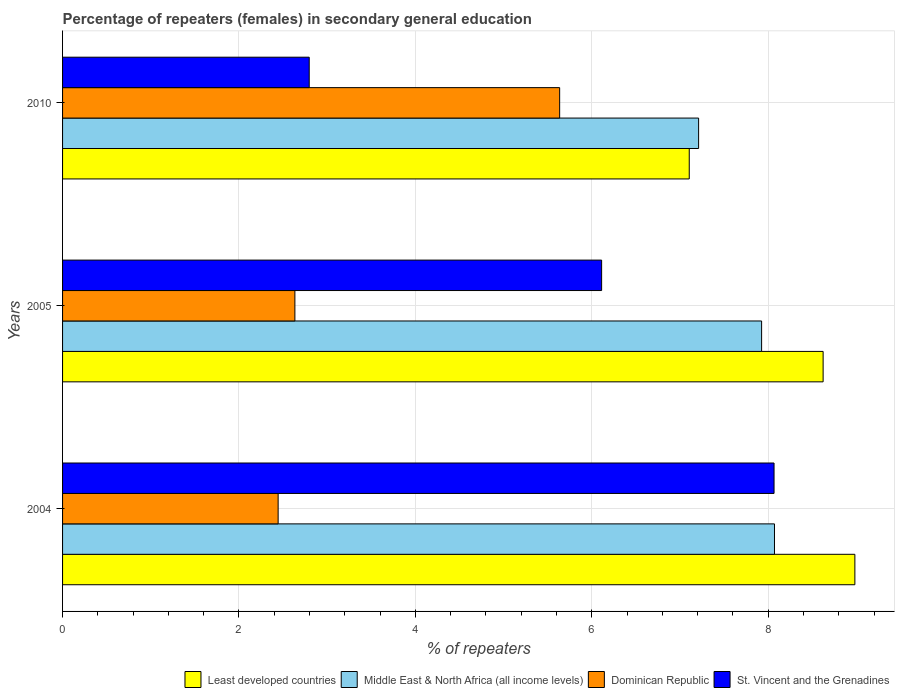How many bars are there on the 3rd tick from the top?
Keep it short and to the point. 4. How many bars are there on the 2nd tick from the bottom?
Your answer should be compact. 4. What is the label of the 2nd group of bars from the top?
Keep it short and to the point. 2005. What is the percentage of female repeaters in Middle East & North Africa (all income levels) in 2005?
Keep it short and to the point. 7.92. Across all years, what is the maximum percentage of female repeaters in Dominican Republic?
Your answer should be compact. 5.64. Across all years, what is the minimum percentage of female repeaters in Middle East & North Africa (all income levels)?
Give a very brief answer. 7.21. In which year was the percentage of female repeaters in Dominican Republic minimum?
Your answer should be very brief. 2004. What is the total percentage of female repeaters in St. Vincent and the Grenadines in the graph?
Your answer should be very brief. 16.97. What is the difference between the percentage of female repeaters in Dominican Republic in 2004 and that in 2010?
Make the answer very short. -3.19. What is the difference between the percentage of female repeaters in Dominican Republic in 2010 and the percentage of female repeaters in Middle East & North Africa (all income levels) in 2005?
Give a very brief answer. -2.29. What is the average percentage of female repeaters in St. Vincent and the Grenadines per year?
Provide a succinct answer. 5.66. In the year 2004, what is the difference between the percentage of female repeaters in St. Vincent and the Grenadines and percentage of female repeaters in Least developed countries?
Provide a succinct answer. -0.92. In how many years, is the percentage of female repeaters in Dominican Republic greater than 4 %?
Offer a very short reply. 1. What is the ratio of the percentage of female repeaters in Middle East & North Africa (all income levels) in 2004 to that in 2010?
Make the answer very short. 1.12. Is the difference between the percentage of female repeaters in St. Vincent and the Grenadines in 2004 and 2005 greater than the difference between the percentage of female repeaters in Least developed countries in 2004 and 2005?
Provide a succinct answer. Yes. What is the difference between the highest and the second highest percentage of female repeaters in Middle East & North Africa (all income levels)?
Ensure brevity in your answer.  0.15. What is the difference between the highest and the lowest percentage of female repeaters in Least developed countries?
Provide a short and direct response. 1.88. In how many years, is the percentage of female repeaters in Dominican Republic greater than the average percentage of female repeaters in Dominican Republic taken over all years?
Your response must be concise. 1. Is it the case that in every year, the sum of the percentage of female repeaters in Least developed countries and percentage of female repeaters in St. Vincent and the Grenadines is greater than the sum of percentage of female repeaters in Middle East & North Africa (all income levels) and percentage of female repeaters in Dominican Republic?
Give a very brief answer. No. What does the 1st bar from the top in 2005 represents?
Keep it short and to the point. St. Vincent and the Grenadines. What does the 3rd bar from the bottom in 2010 represents?
Give a very brief answer. Dominican Republic. Are all the bars in the graph horizontal?
Your answer should be very brief. Yes. How many years are there in the graph?
Provide a short and direct response. 3. Are the values on the major ticks of X-axis written in scientific E-notation?
Offer a very short reply. No. Does the graph contain any zero values?
Offer a very short reply. No. Does the graph contain grids?
Keep it short and to the point. Yes. Where does the legend appear in the graph?
Your answer should be compact. Bottom right. What is the title of the graph?
Ensure brevity in your answer.  Percentage of repeaters (females) in secondary general education. Does "United Kingdom" appear as one of the legend labels in the graph?
Provide a short and direct response. No. What is the label or title of the X-axis?
Your answer should be very brief. % of repeaters. What is the label or title of the Y-axis?
Provide a short and direct response. Years. What is the % of repeaters in Least developed countries in 2004?
Your answer should be compact. 8.98. What is the % of repeaters of Middle East & North Africa (all income levels) in 2004?
Your response must be concise. 8.07. What is the % of repeaters in Dominican Republic in 2004?
Provide a short and direct response. 2.44. What is the % of repeaters in St. Vincent and the Grenadines in 2004?
Provide a short and direct response. 8.07. What is the % of repeaters in Least developed countries in 2005?
Ensure brevity in your answer.  8.62. What is the % of repeaters in Middle East & North Africa (all income levels) in 2005?
Your answer should be very brief. 7.92. What is the % of repeaters in Dominican Republic in 2005?
Offer a very short reply. 2.63. What is the % of repeaters of St. Vincent and the Grenadines in 2005?
Your response must be concise. 6.11. What is the % of repeaters of Least developed countries in 2010?
Your answer should be very brief. 7.1. What is the % of repeaters in Middle East & North Africa (all income levels) in 2010?
Provide a short and direct response. 7.21. What is the % of repeaters in Dominican Republic in 2010?
Your answer should be very brief. 5.64. What is the % of repeaters in St. Vincent and the Grenadines in 2010?
Make the answer very short. 2.8. Across all years, what is the maximum % of repeaters of Least developed countries?
Your answer should be very brief. 8.98. Across all years, what is the maximum % of repeaters in Middle East & North Africa (all income levels)?
Give a very brief answer. 8.07. Across all years, what is the maximum % of repeaters of Dominican Republic?
Make the answer very short. 5.64. Across all years, what is the maximum % of repeaters in St. Vincent and the Grenadines?
Keep it short and to the point. 8.07. Across all years, what is the minimum % of repeaters of Least developed countries?
Your response must be concise. 7.1. Across all years, what is the minimum % of repeaters of Middle East & North Africa (all income levels)?
Give a very brief answer. 7.21. Across all years, what is the minimum % of repeaters in Dominican Republic?
Offer a terse response. 2.44. Across all years, what is the minimum % of repeaters of St. Vincent and the Grenadines?
Offer a terse response. 2.8. What is the total % of repeaters of Least developed countries in the graph?
Make the answer very short. 24.71. What is the total % of repeaters in Middle East & North Africa (all income levels) in the graph?
Provide a succinct answer. 23.21. What is the total % of repeaters in Dominican Republic in the graph?
Offer a terse response. 10.71. What is the total % of repeaters in St. Vincent and the Grenadines in the graph?
Your answer should be compact. 16.97. What is the difference between the % of repeaters of Least developed countries in 2004 and that in 2005?
Keep it short and to the point. 0.36. What is the difference between the % of repeaters of Middle East & North Africa (all income levels) in 2004 and that in 2005?
Your answer should be compact. 0.15. What is the difference between the % of repeaters in Dominican Republic in 2004 and that in 2005?
Provide a succinct answer. -0.19. What is the difference between the % of repeaters in St. Vincent and the Grenadines in 2004 and that in 2005?
Provide a succinct answer. 1.95. What is the difference between the % of repeaters in Least developed countries in 2004 and that in 2010?
Ensure brevity in your answer.  1.88. What is the difference between the % of repeaters of Middle East & North Africa (all income levels) in 2004 and that in 2010?
Make the answer very short. 0.86. What is the difference between the % of repeaters of Dominican Republic in 2004 and that in 2010?
Your response must be concise. -3.19. What is the difference between the % of repeaters in St. Vincent and the Grenadines in 2004 and that in 2010?
Give a very brief answer. 5.27. What is the difference between the % of repeaters of Least developed countries in 2005 and that in 2010?
Offer a very short reply. 1.52. What is the difference between the % of repeaters in Middle East & North Africa (all income levels) in 2005 and that in 2010?
Your response must be concise. 0.71. What is the difference between the % of repeaters of Dominican Republic in 2005 and that in 2010?
Provide a succinct answer. -3. What is the difference between the % of repeaters in St. Vincent and the Grenadines in 2005 and that in 2010?
Your answer should be compact. 3.31. What is the difference between the % of repeaters in Least developed countries in 2004 and the % of repeaters in Middle East & North Africa (all income levels) in 2005?
Provide a short and direct response. 1.06. What is the difference between the % of repeaters in Least developed countries in 2004 and the % of repeaters in Dominican Republic in 2005?
Keep it short and to the point. 6.35. What is the difference between the % of repeaters of Least developed countries in 2004 and the % of repeaters of St. Vincent and the Grenadines in 2005?
Ensure brevity in your answer.  2.87. What is the difference between the % of repeaters of Middle East & North Africa (all income levels) in 2004 and the % of repeaters of Dominican Republic in 2005?
Give a very brief answer. 5.44. What is the difference between the % of repeaters in Middle East & North Africa (all income levels) in 2004 and the % of repeaters in St. Vincent and the Grenadines in 2005?
Give a very brief answer. 1.96. What is the difference between the % of repeaters in Dominican Republic in 2004 and the % of repeaters in St. Vincent and the Grenadines in 2005?
Offer a very short reply. -3.67. What is the difference between the % of repeaters of Least developed countries in 2004 and the % of repeaters of Middle East & North Africa (all income levels) in 2010?
Provide a short and direct response. 1.77. What is the difference between the % of repeaters in Least developed countries in 2004 and the % of repeaters in Dominican Republic in 2010?
Give a very brief answer. 3.35. What is the difference between the % of repeaters of Least developed countries in 2004 and the % of repeaters of St. Vincent and the Grenadines in 2010?
Provide a short and direct response. 6.19. What is the difference between the % of repeaters in Middle East & North Africa (all income levels) in 2004 and the % of repeaters in Dominican Republic in 2010?
Your answer should be very brief. 2.44. What is the difference between the % of repeaters in Middle East & North Africa (all income levels) in 2004 and the % of repeaters in St. Vincent and the Grenadines in 2010?
Your response must be concise. 5.27. What is the difference between the % of repeaters in Dominican Republic in 2004 and the % of repeaters in St. Vincent and the Grenadines in 2010?
Give a very brief answer. -0.35. What is the difference between the % of repeaters of Least developed countries in 2005 and the % of repeaters of Middle East & North Africa (all income levels) in 2010?
Ensure brevity in your answer.  1.41. What is the difference between the % of repeaters in Least developed countries in 2005 and the % of repeaters in Dominican Republic in 2010?
Provide a succinct answer. 2.99. What is the difference between the % of repeaters in Least developed countries in 2005 and the % of repeaters in St. Vincent and the Grenadines in 2010?
Your response must be concise. 5.83. What is the difference between the % of repeaters in Middle East & North Africa (all income levels) in 2005 and the % of repeaters in Dominican Republic in 2010?
Keep it short and to the point. 2.29. What is the difference between the % of repeaters in Middle East & North Africa (all income levels) in 2005 and the % of repeaters in St. Vincent and the Grenadines in 2010?
Keep it short and to the point. 5.13. What is the difference between the % of repeaters of Dominican Republic in 2005 and the % of repeaters of St. Vincent and the Grenadines in 2010?
Give a very brief answer. -0.16. What is the average % of repeaters in Least developed countries per year?
Your response must be concise. 8.24. What is the average % of repeaters of Middle East & North Africa (all income levels) per year?
Provide a short and direct response. 7.74. What is the average % of repeaters in Dominican Republic per year?
Provide a succinct answer. 3.57. What is the average % of repeaters of St. Vincent and the Grenadines per year?
Offer a terse response. 5.66. In the year 2004, what is the difference between the % of repeaters of Least developed countries and % of repeaters of Middle East & North Africa (all income levels)?
Provide a short and direct response. 0.91. In the year 2004, what is the difference between the % of repeaters in Least developed countries and % of repeaters in Dominican Republic?
Your response must be concise. 6.54. In the year 2004, what is the difference between the % of repeaters of Least developed countries and % of repeaters of St. Vincent and the Grenadines?
Your answer should be compact. 0.92. In the year 2004, what is the difference between the % of repeaters of Middle East & North Africa (all income levels) and % of repeaters of Dominican Republic?
Offer a very short reply. 5.63. In the year 2004, what is the difference between the % of repeaters in Middle East & North Africa (all income levels) and % of repeaters in St. Vincent and the Grenadines?
Provide a succinct answer. 0.01. In the year 2004, what is the difference between the % of repeaters in Dominican Republic and % of repeaters in St. Vincent and the Grenadines?
Give a very brief answer. -5.62. In the year 2005, what is the difference between the % of repeaters of Least developed countries and % of repeaters of Middle East & North Africa (all income levels)?
Make the answer very short. 0.7. In the year 2005, what is the difference between the % of repeaters in Least developed countries and % of repeaters in Dominican Republic?
Give a very brief answer. 5.99. In the year 2005, what is the difference between the % of repeaters of Least developed countries and % of repeaters of St. Vincent and the Grenadines?
Provide a short and direct response. 2.51. In the year 2005, what is the difference between the % of repeaters in Middle East & North Africa (all income levels) and % of repeaters in Dominican Republic?
Your answer should be very brief. 5.29. In the year 2005, what is the difference between the % of repeaters in Middle East & North Africa (all income levels) and % of repeaters in St. Vincent and the Grenadines?
Your response must be concise. 1.81. In the year 2005, what is the difference between the % of repeaters of Dominican Republic and % of repeaters of St. Vincent and the Grenadines?
Offer a terse response. -3.48. In the year 2010, what is the difference between the % of repeaters in Least developed countries and % of repeaters in Middle East & North Africa (all income levels)?
Offer a terse response. -0.11. In the year 2010, what is the difference between the % of repeaters in Least developed countries and % of repeaters in Dominican Republic?
Give a very brief answer. 1.47. In the year 2010, what is the difference between the % of repeaters of Least developed countries and % of repeaters of St. Vincent and the Grenadines?
Give a very brief answer. 4.31. In the year 2010, what is the difference between the % of repeaters of Middle East & North Africa (all income levels) and % of repeaters of Dominican Republic?
Your response must be concise. 1.58. In the year 2010, what is the difference between the % of repeaters in Middle East & North Africa (all income levels) and % of repeaters in St. Vincent and the Grenadines?
Offer a terse response. 4.41. In the year 2010, what is the difference between the % of repeaters of Dominican Republic and % of repeaters of St. Vincent and the Grenadines?
Offer a terse response. 2.84. What is the ratio of the % of repeaters in Least developed countries in 2004 to that in 2005?
Provide a short and direct response. 1.04. What is the ratio of the % of repeaters in Middle East & North Africa (all income levels) in 2004 to that in 2005?
Your answer should be very brief. 1.02. What is the ratio of the % of repeaters in Dominican Republic in 2004 to that in 2005?
Your answer should be compact. 0.93. What is the ratio of the % of repeaters of St. Vincent and the Grenadines in 2004 to that in 2005?
Ensure brevity in your answer.  1.32. What is the ratio of the % of repeaters of Least developed countries in 2004 to that in 2010?
Provide a short and direct response. 1.26. What is the ratio of the % of repeaters of Middle East & North Africa (all income levels) in 2004 to that in 2010?
Provide a short and direct response. 1.12. What is the ratio of the % of repeaters in Dominican Republic in 2004 to that in 2010?
Give a very brief answer. 0.43. What is the ratio of the % of repeaters of St. Vincent and the Grenadines in 2004 to that in 2010?
Your answer should be very brief. 2.88. What is the ratio of the % of repeaters of Least developed countries in 2005 to that in 2010?
Ensure brevity in your answer.  1.21. What is the ratio of the % of repeaters of Middle East & North Africa (all income levels) in 2005 to that in 2010?
Provide a short and direct response. 1.1. What is the ratio of the % of repeaters in Dominican Republic in 2005 to that in 2010?
Provide a succinct answer. 0.47. What is the ratio of the % of repeaters of St. Vincent and the Grenadines in 2005 to that in 2010?
Keep it short and to the point. 2.19. What is the difference between the highest and the second highest % of repeaters of Least developed countries?
Keep it short and to the point. 0.36. What is the difference between the highest and the second highest % of repeaters in Middle East & North Africa (all income levels)?
Offer a very short reply. 0.15. What is the difference between the highest and the second highest % of repeaters of Dominican Republic?
Give a very brief answer. 3. What is the difference between the highest and the second highest % of repeaters of St. Vincent and the Grenadines?
Ensure brevity in your answer.  1.95. What is the difference between the highest and the lowest % of repeaters of Least developed countries?
Provide a short and direct response. 1.88. What is the difference between the highest and the lowest % of repeaters of Middle East & North Africa (all income levels)?
Keep it short and to the point. 0.86. What is the difference between the highest and the lowest % of repeaters in Dominican Republic?
Keep it short and to the point. 3.19. What is the difference between the highest and the lowest % of repeaters in St. Vincent and the Grenadines?
Keep it short and to the point. 5.27. 